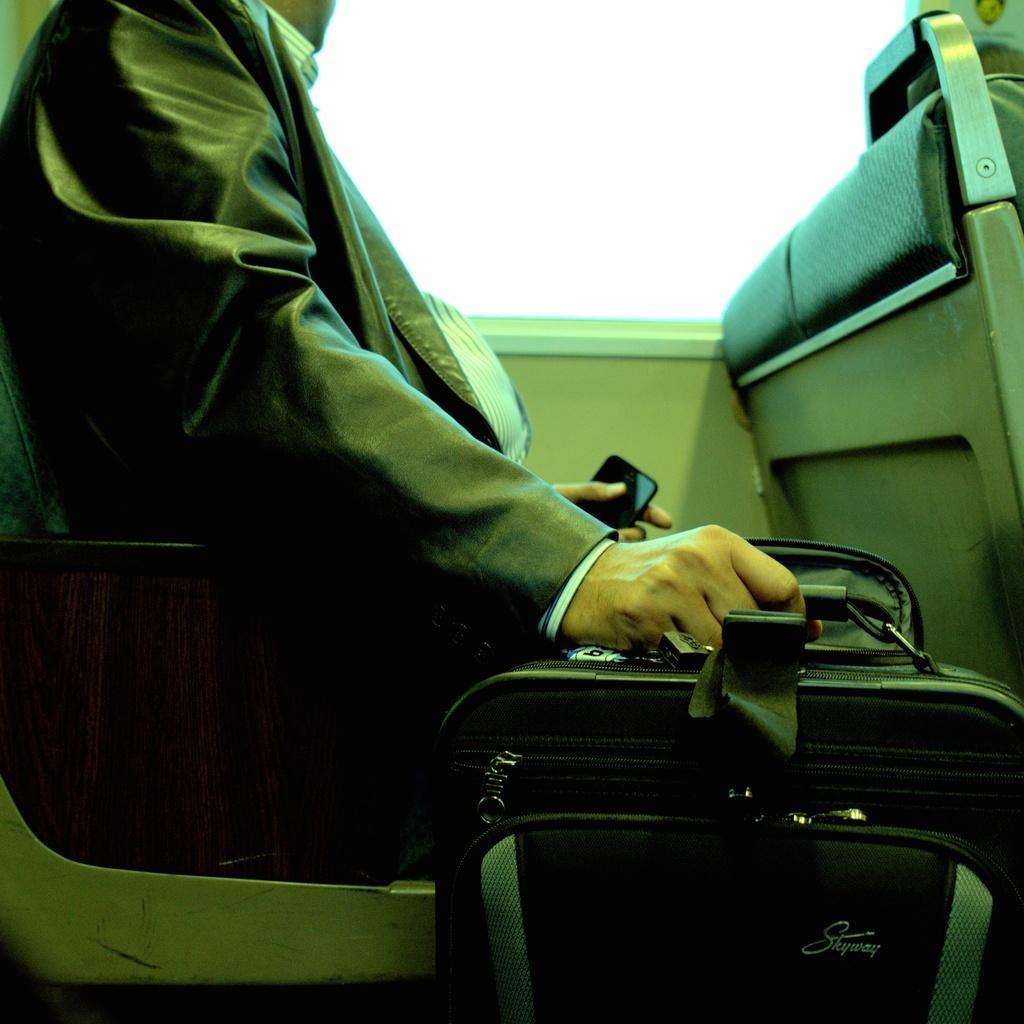Please provide a concise description of this image. A man is sitting on the chair and holding bag in his hand on the other hand a mobile. 